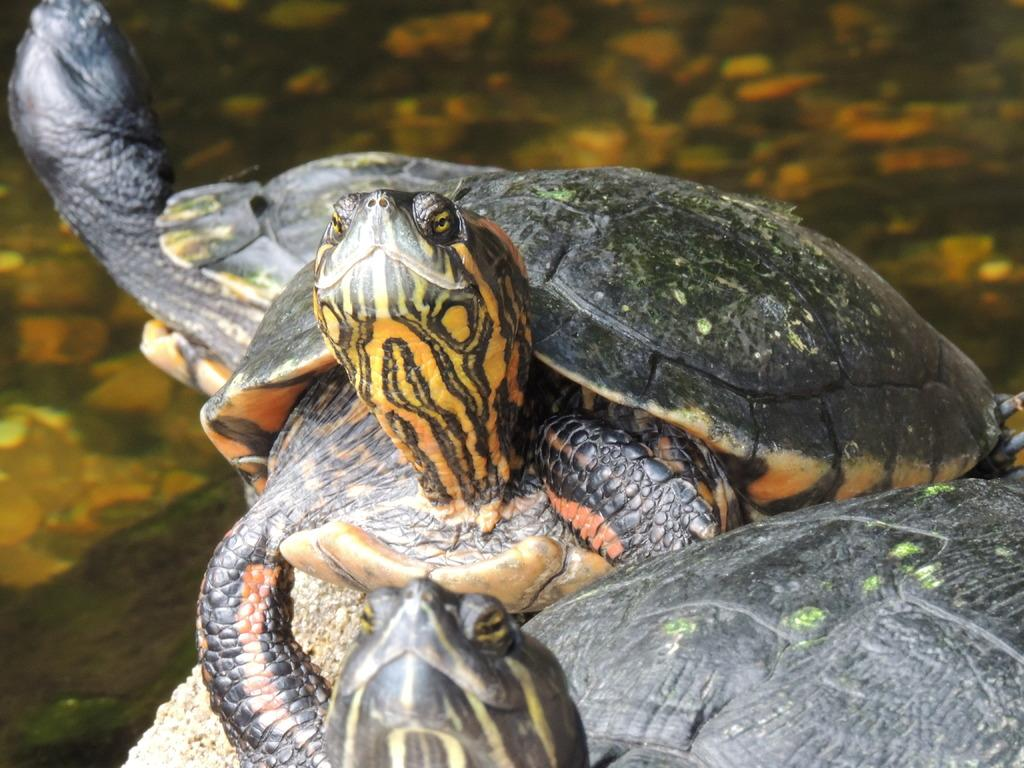How many turtles are present in the image? There are three turtles in the image. What type of turtles are featured in the image? The turtles are Florida-red belly turtles. What type of bikes can be seen in the image? There are no bikes present in the image; it features three Florida-red belly turtles. What type of milk is being consumed by the turtles in the image? The turtles do not consume milk, as they are reptiles and do not drink milk. 